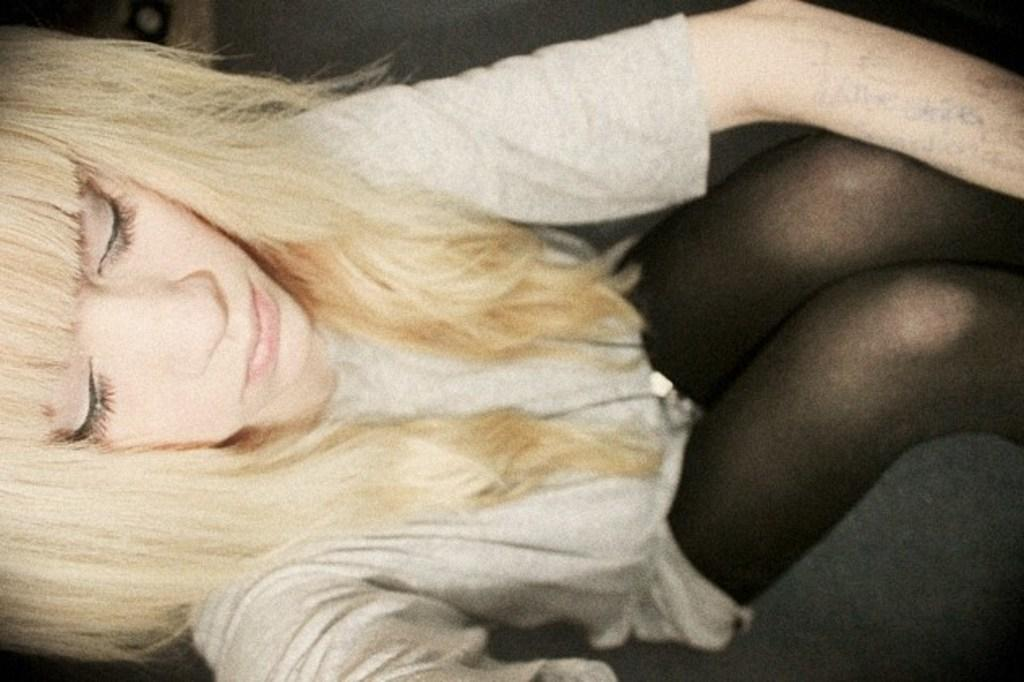Who is the main subject in the image? There is a woman in the image. What is the woman wearing? The woman is wearing a grey top. Can you describe any additional details about the woman? There is something written on the woman's hand. Who is the owner of the corn in the image? There is no corn present in the image, so it is not possible to determine the owner. 